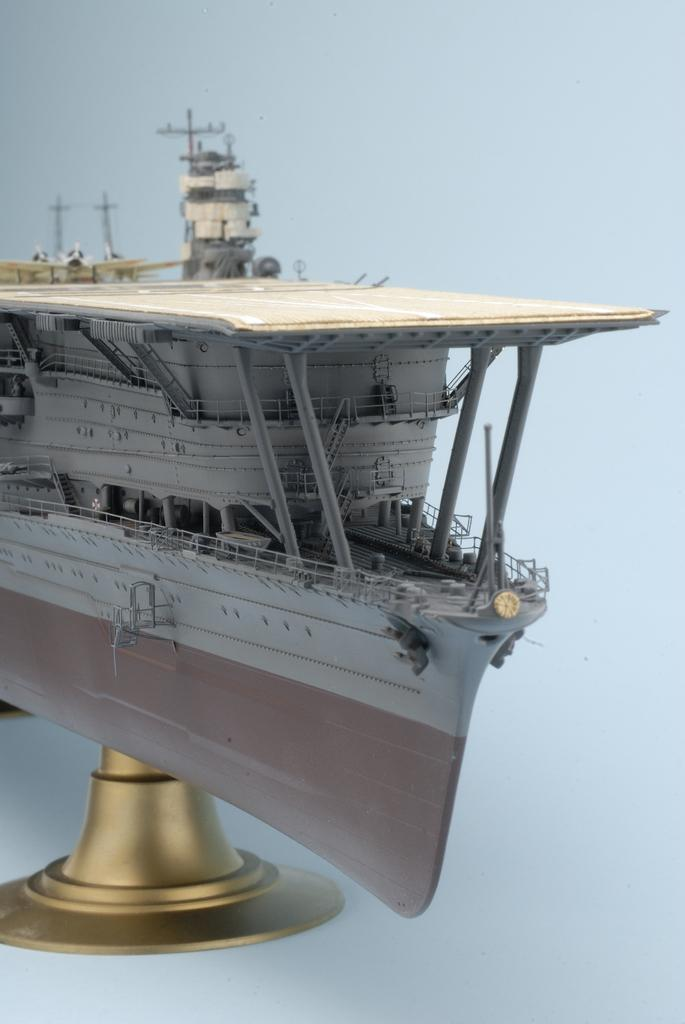What is the main subject of the image? The main subject of the image is a model of a ship. How is the ship displayed in the image? The ship is on a stand in the image. What features can be seen on the ship? The ship has railings and pillars. What is the color of the background in the image? The background color is light blue. What type of fang can be seen on the ship in the image? There are no fangs present on the ship in the image; it is a model of a ship with railings and pillars. What type of bushes are growing around the ship in the image? There are no bushes present in the image; the background is a light blue color. 